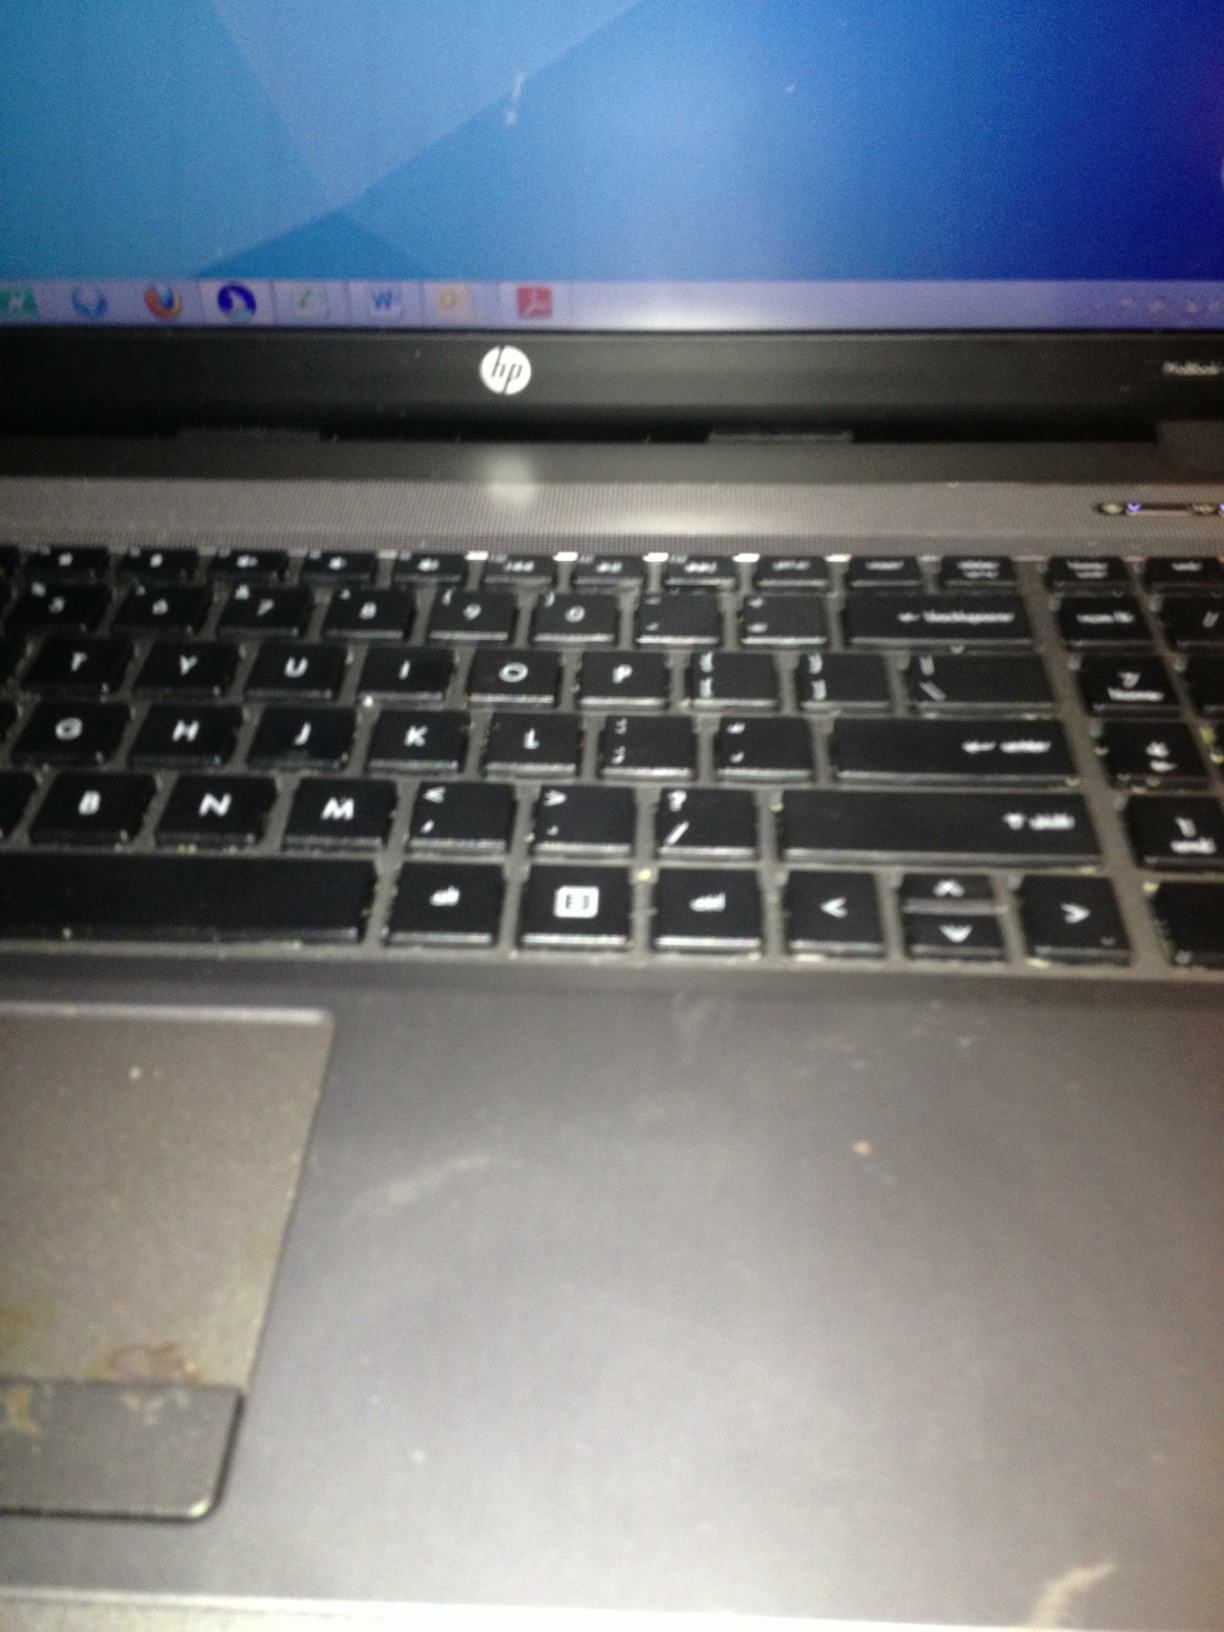Describe the connectivity options available on this HP laptop, including the available ports and their positions. This HP laptop appears to have a variety of connectivity options. Common ports include USB ports, an HDMI port, and possibly an SD card reader. The USB ports are typically located on the sides of the laptop, alongside the HDMI port. The card reader, if present, is usually situated on the side as well. For precise information, please refer to the product specifications or user manual of this specific HP laptop model 